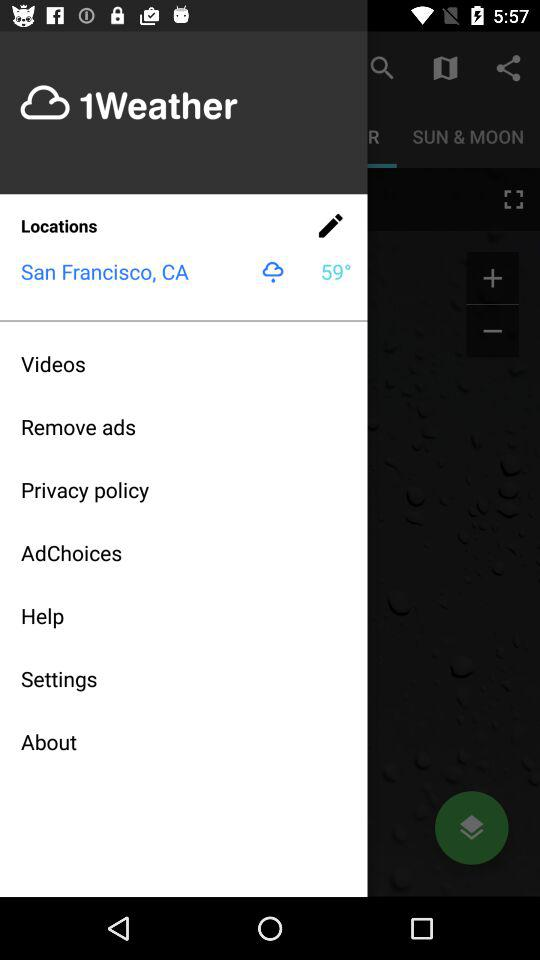How is the weather? The weather is slightly rainy. 